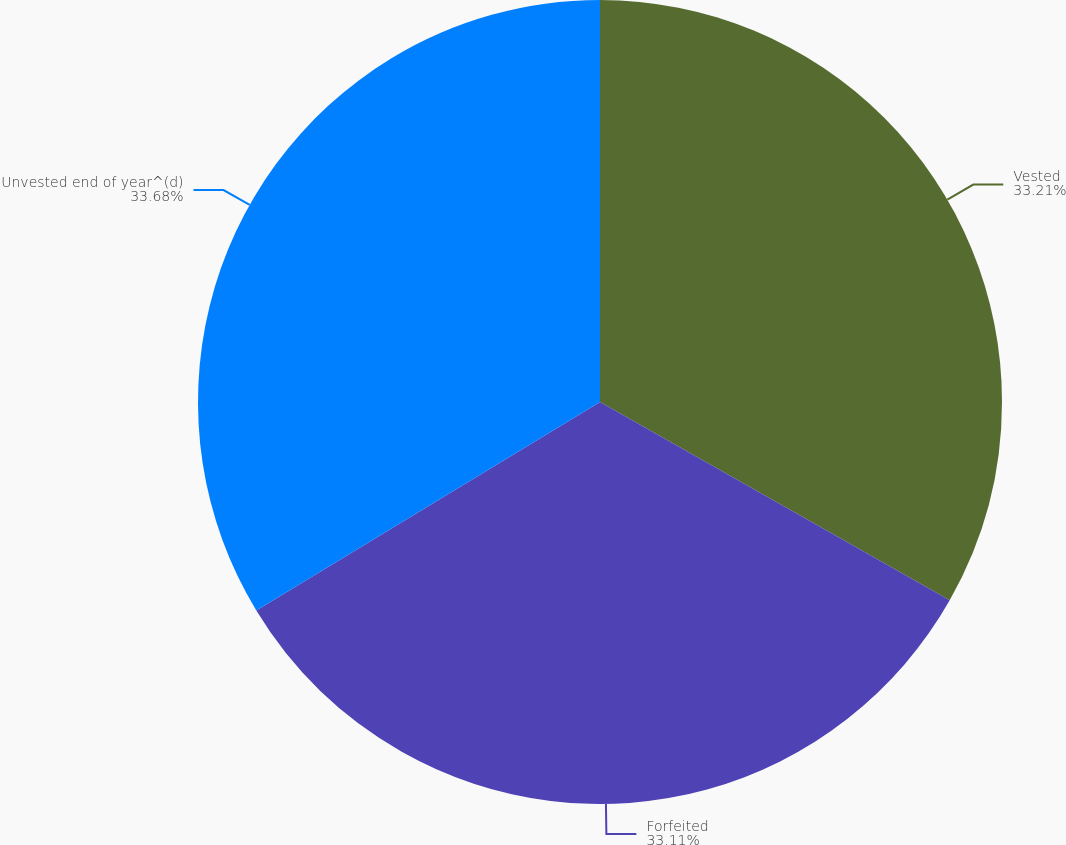Convert chart to OTSL. <chart><loc_0><loc_0><loc_500><loc_500><pie_chart><fcel>Vested<fcel>Forfeited<fcel>Unvested end of year^(d)<nl><fcel>33.21%<fcel>33.11%<fcel>33.68%<nl></chart> 